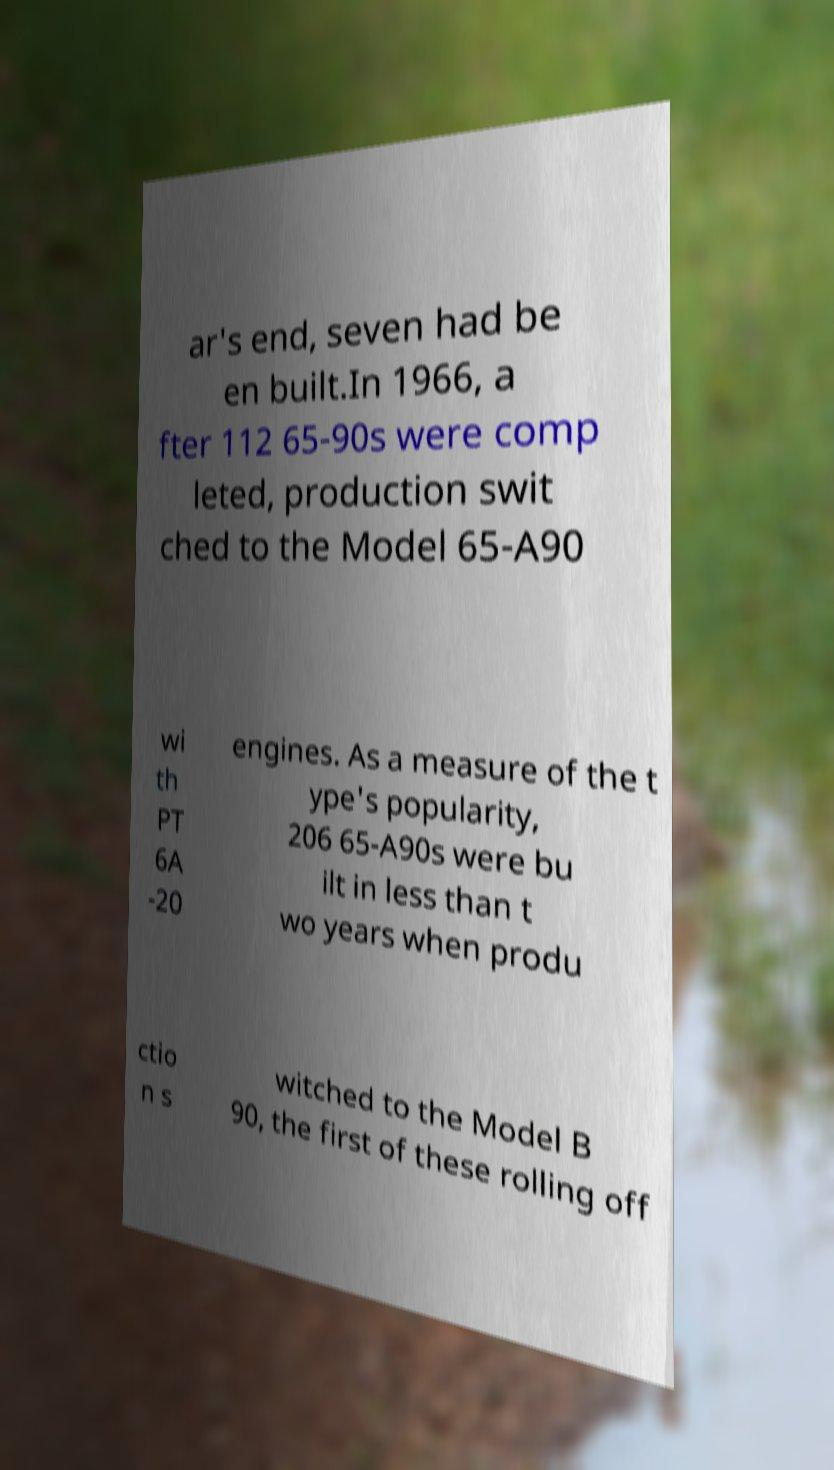Could you extract and type out the text from this image? ar's end, seven had be en built.In 1966, a fter 112 65-90s were comp leted, production swit ched to the Model 65-A90 wi th PT 6A -20 engines. As a measure of the t ype's popularity, 206 65-A90s were bu ilt in less than t wo years when produ ctio n s witched to the Model B 90, the first of these rolling off 